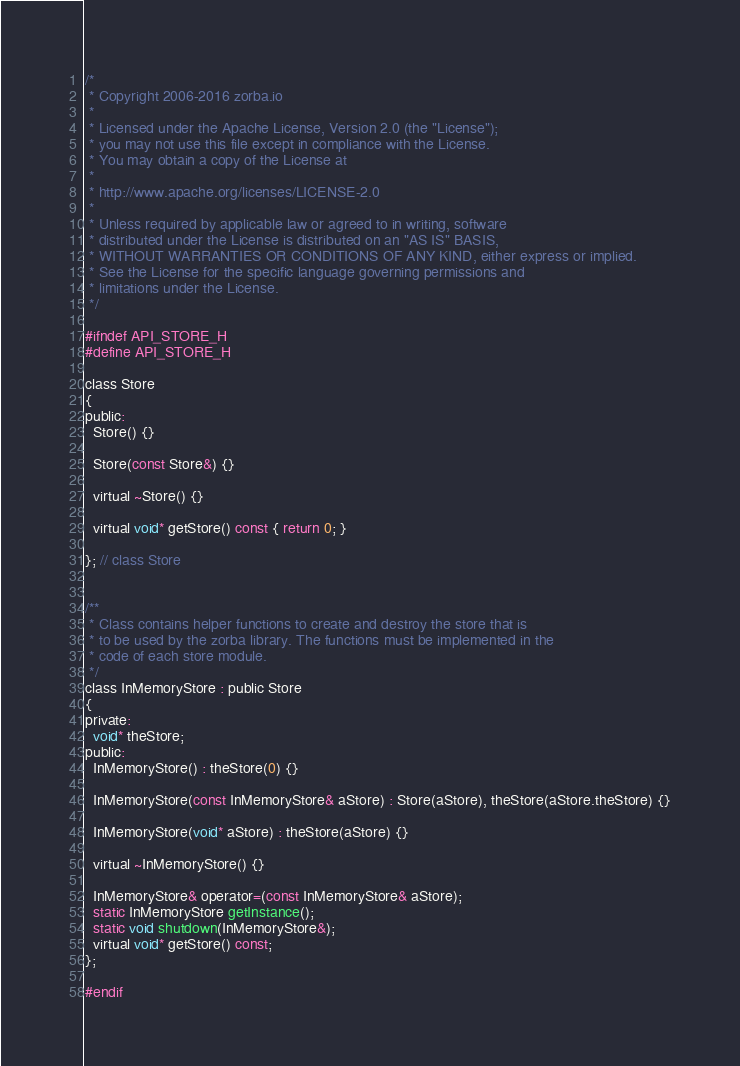Convert code to text. <code><loc_0><loc_0><loc_500><loc_500><_C_>/*
 * Copyright 2006-2016 zorba.io
 *
 * Licensed under the Apache License, Version 2.0 (the "License");
 * you may not use this file except in compliance with the License.
 * You may obtain a copy of the License at
 * 
 * http://www.apache.org/licenses/LICENSE-2.0
 *
 * Unless required by applicable law or agreed to in writing, software
 * distributed under the License is distributed on an "AS IS" BASIS,
 * WITHOUT WARRANTIES OR CONDITIONS OF ANY KIND, either express or implied.
 * See the License for the specific language governing permissions and
 * limitations under the License.
 */

#ifndef API_STORE_H
#define API_STORE_H

class Store 
{
public:
  Store() {}

  Store(const Store&) {}

  virtual ~Store() {}

  virtual void* getStore() const { return 0; }

}; // class Store


/**
 * Class contains helper functions to create and destroy the store that is 
 * to be used by the zorba library. The functions must be implemented in the
 * code of each store module.
 */
class InMemoryStore : public Store 
{
private:
  void* theStore;
public:
  InMemoryStore() : theStore(0) {}

  InMemoryStore(const InMemoryStore& aStore) : Store(aStore), theStore(aStore.theStore) {}

  InMemoryStore(void* aStore) : theStore(aStore) {}

  virtual ~InMemoryStore() {}

  InMemoryStore& operator=(const InMemoryStore& aStore);
  static InMemoryStore getInstance();
  static void shutdown(InMemoryStore&);
  virtual void* getStore() const;
};

#endif
</code> 